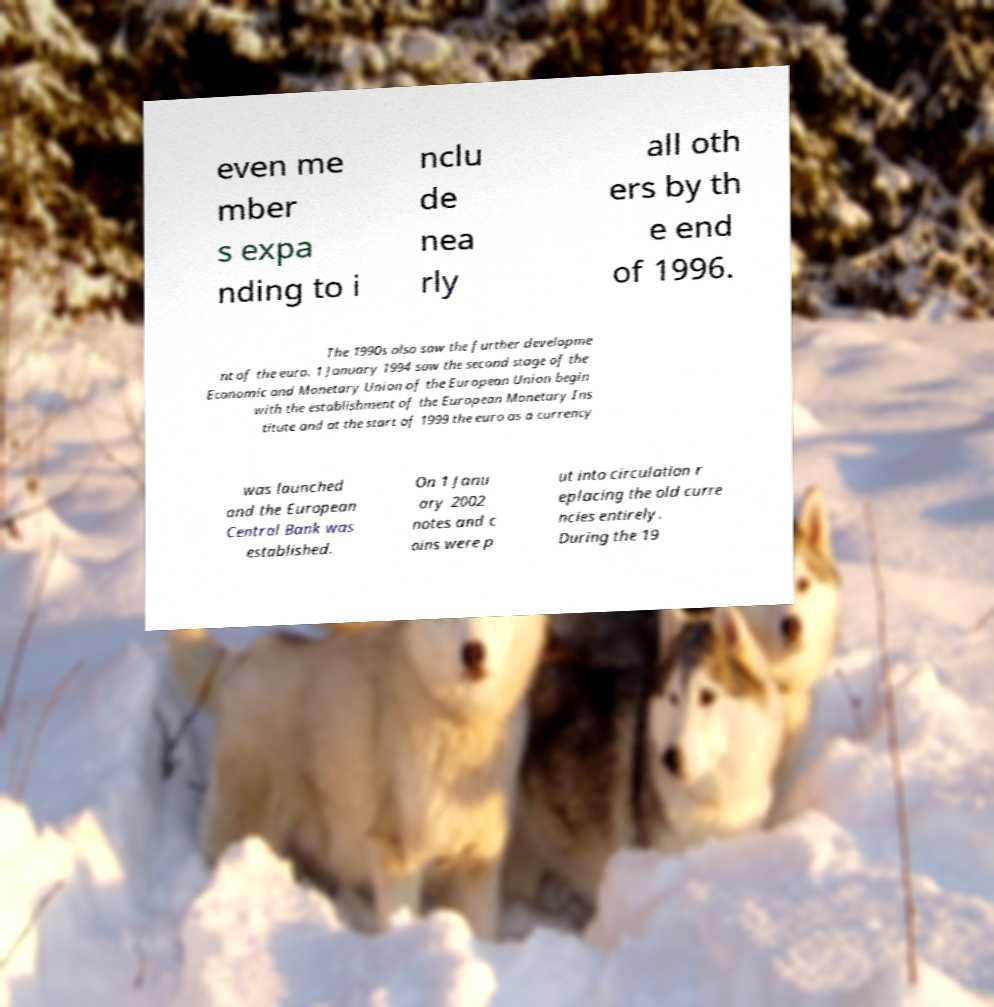What messages or text are displayed in this image? I need them in a readable, typed format. even me mber s expa nding to i nclu de nea rly all oth ers by th e end of 1996. The 1990s also saw the further developme nt of the euro. 1 January 1994 saw the second stage of the Economic and Monetary Union of the European Union begin with the establishment of the European Monetary Ins titute and at the start of 1999 the euro as a currency was launched and the European Central Bank was established. On 1 Janu ary 2002 notes and c oins were p ut into circulation r eplacing the old curre ncies entirely. During the 19 